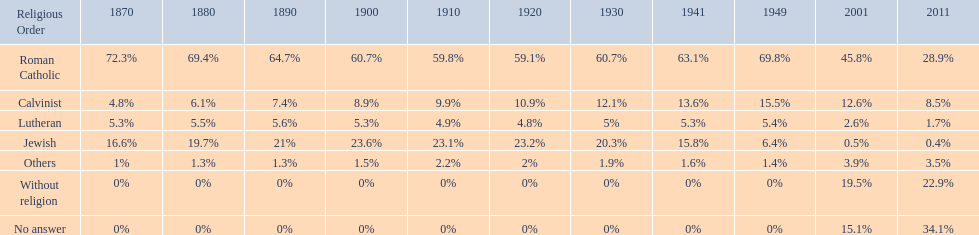Which denomination held the largest percentage in 1880? Roman Catholic. 